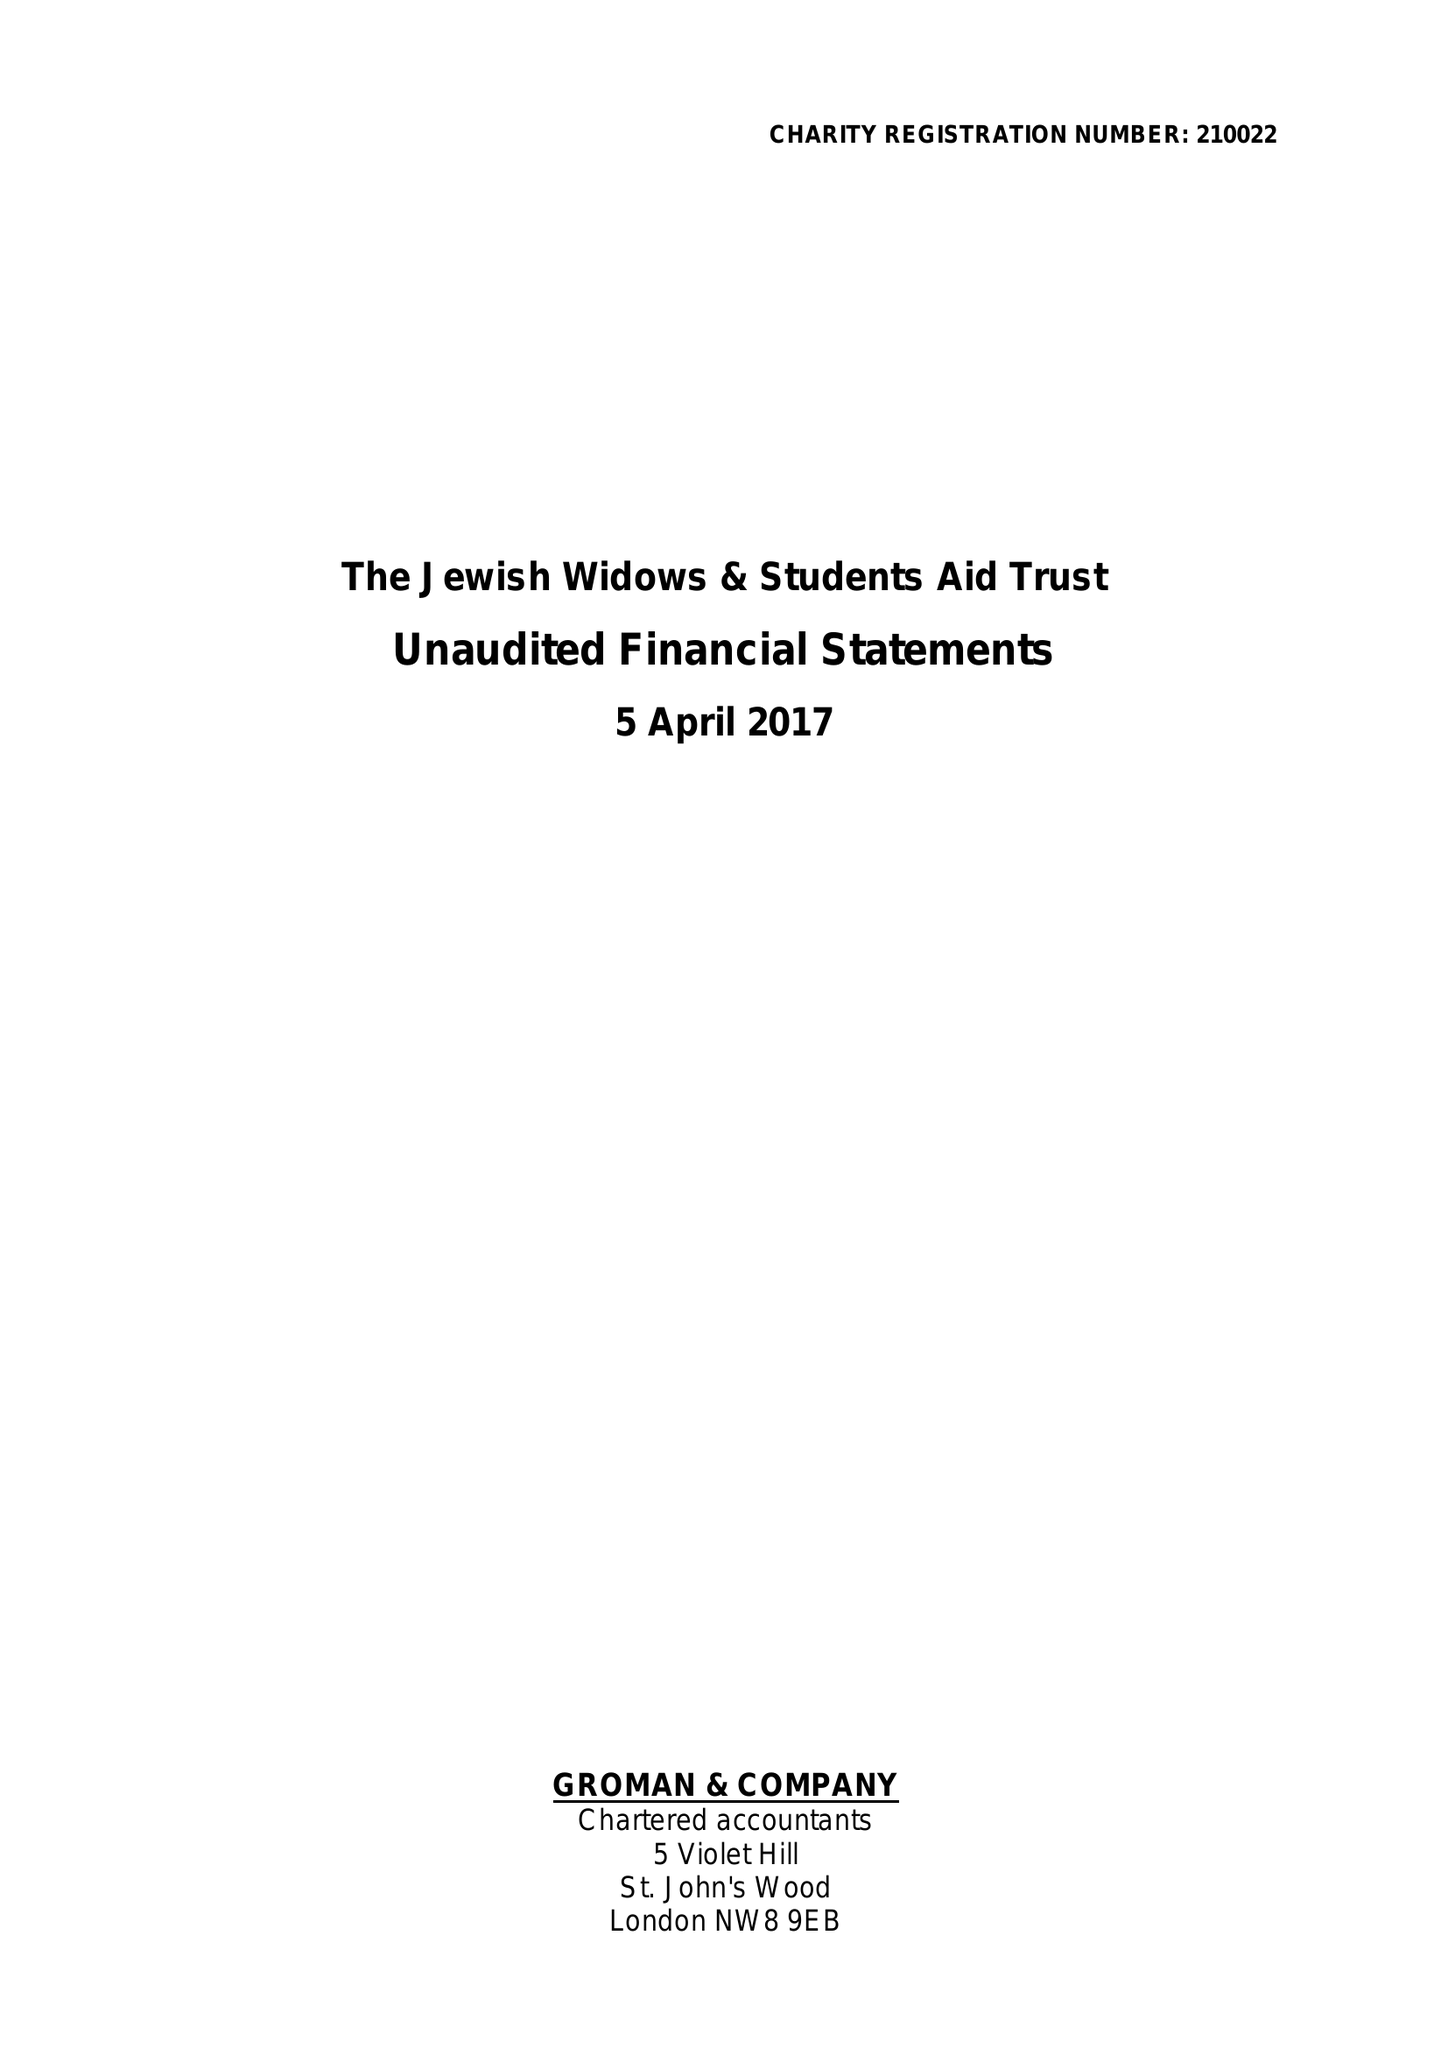What is the value for the address__street_line?
Answer the question using a single word or phrase. 5 RAEBURN CLOSE 